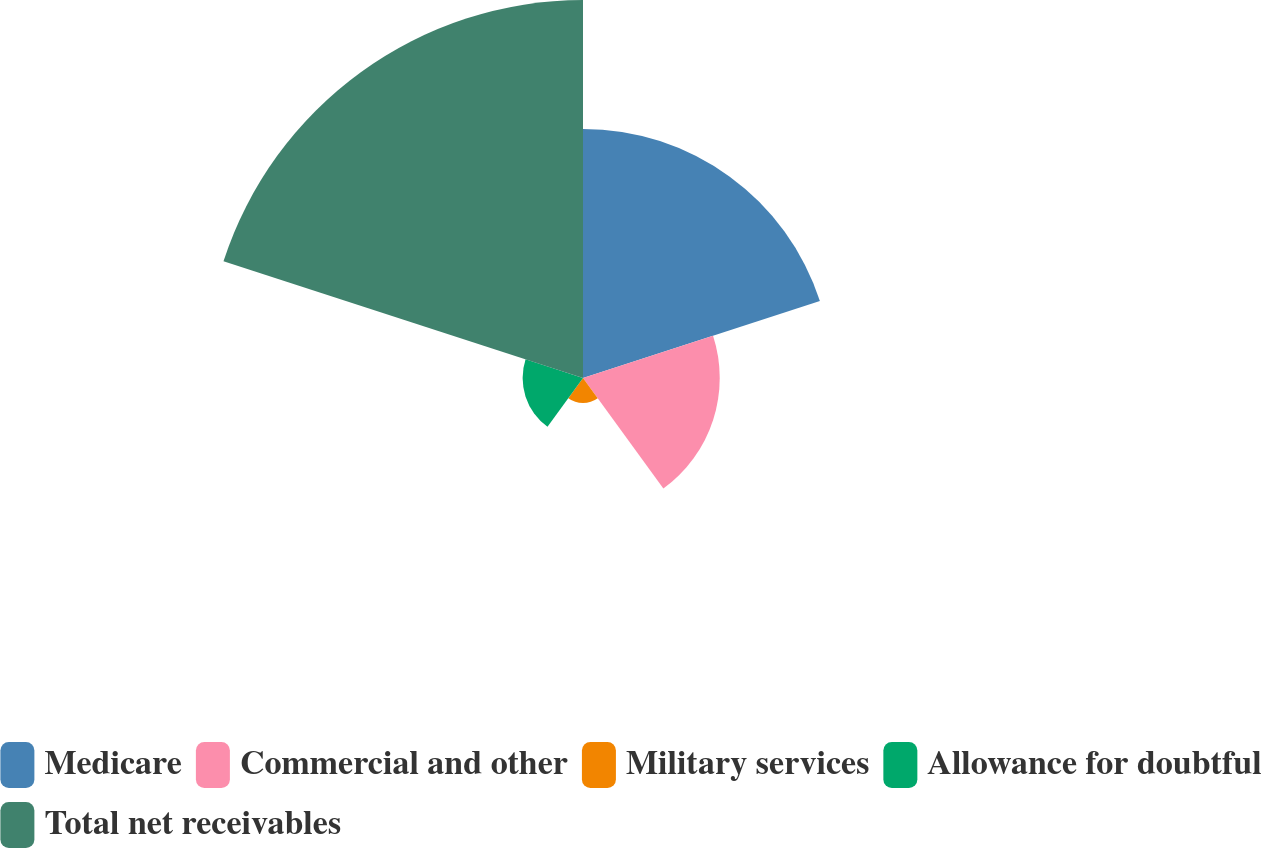Convert chart to OTSL. <chart><loc_0><loc_0><loc_500><loc_500><pie_chart><fcel>Medicare<fcel>Commercial and other<fcel>Military services<fcel>Allowance for doubtful<fcel>Total net receivables<nl><fcel>29.33%<fcel>16.1%<fcel>2.95%<fcel>7.11%<fcel>44.51%<nl></chart> 